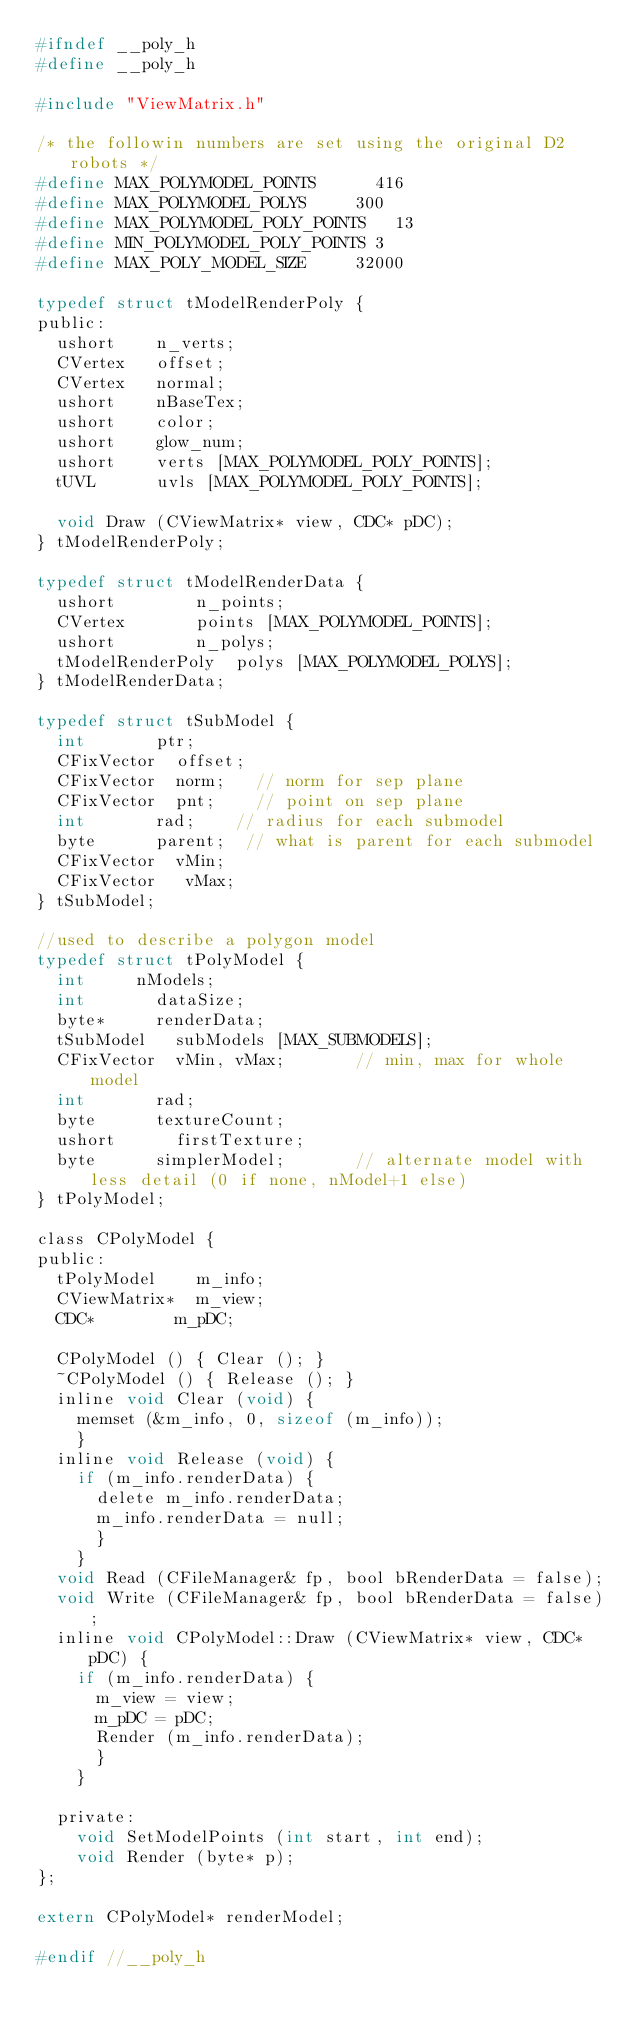Convert code to text. <code><loc_0><loc_0><loc_500><loc_500><_C_>#ifndef __poly_h
#define __poly_h

#include "ViewMatrix.h"

/* the followin numbers are set using the original D2 robots */
#define MAX_POLYMODEL_POINTS			416
#define MAX_POLYMODEL_POLYS			300
#define MAX_POLYMODEL_POLY_POINTS   13
#define MIN_POLYMODEL_POLY_POINTS	3
#define MAX_POLY_MODEL_SIZE			32000

typedef struct tModelRenderPoly {
public:
	ushort		n_verts;
	CVertex		offset;
	CVertex		normal;
	ushort		nBaseTex;
	ushort		color;
	ushort		glow_num;
	ushort		verts [MAX_POLYMODEL_POLY_POINTS];
	tUVL			uvls [MAX_POLYMODEL_POLY_POINTS];

	void Draw (CViewMatrix* view, CDC* pDC);
} tModelRenderPoly;

typedef struct tModelRenderData {
	ushort				n_points;
	CVertex				points [MAX_POLYMODEL_POINTS];
	ushort				n_polys;
	tModelRenderPoly	polys [MAX_POLYMODEL_POLYS];
} tModelRenderData;

typedef struct tSubModel {
  int 			ptr;
  CFixVector 	offset;
  CFixVector 	norm;		// norm for sep plane
  CFixVector 	pnt;		// point on sep plane
  int 			rad;		// radius for each submodel
  byte 			parent;  // what is parent for each submodel
  CFixVector 	vMin;
  CFixVector   vMax;
} tSubModel;

//used to describe a polygon model
typedef struct tPolyModel {
  int			nModels;
  int 			dataSize;
  byte*			renderData;
  tSubModel		subModels [MAX_SUBMODELS];
  CFixVector 	vMin, vMax;			  // min, max for whole model
  int				rad;
  byte			textureCount;
  ushort			firstTexture;
  byte			simplerModel;			  // alternate model with less detail (0 if none, nModel+1 else)
} tPolyModel;

class CPolyModel {
public:
	tPolyModel		m_info;
	CViewMatrix*	m_view;
	CDC*				m_pDC;

	CPolyModel () { Clear (); }
	~CPolyModel () { Release (); }
	inline void Clear (void) { 
		memset (&m_info, 0, sizeof (m_info)); 
		}
	inline void Release (void) {
		if (m_info.renderData) {
			delete m_info.renderData;
			m_info.renderData = null;
			}
		}
	void Read (CFileManager& fp, bool bRenderData = false);
	void Write (CFileManager& fp, bool bRenderData = false);
	inline void CPolyModel::Draw (CViewMatrix* view, CDC* pDC) {
		if (m_info.renderData) {
			m_view = view;
			m_pDC = pDC;
			Render (m_info.renderData);
			}
		}

	private:
		void SetModelPoints (int start, int end);
		void Render (byte* p);
};

extern CPolyModel* renderModel;

#endif //__poly_h
</code> 